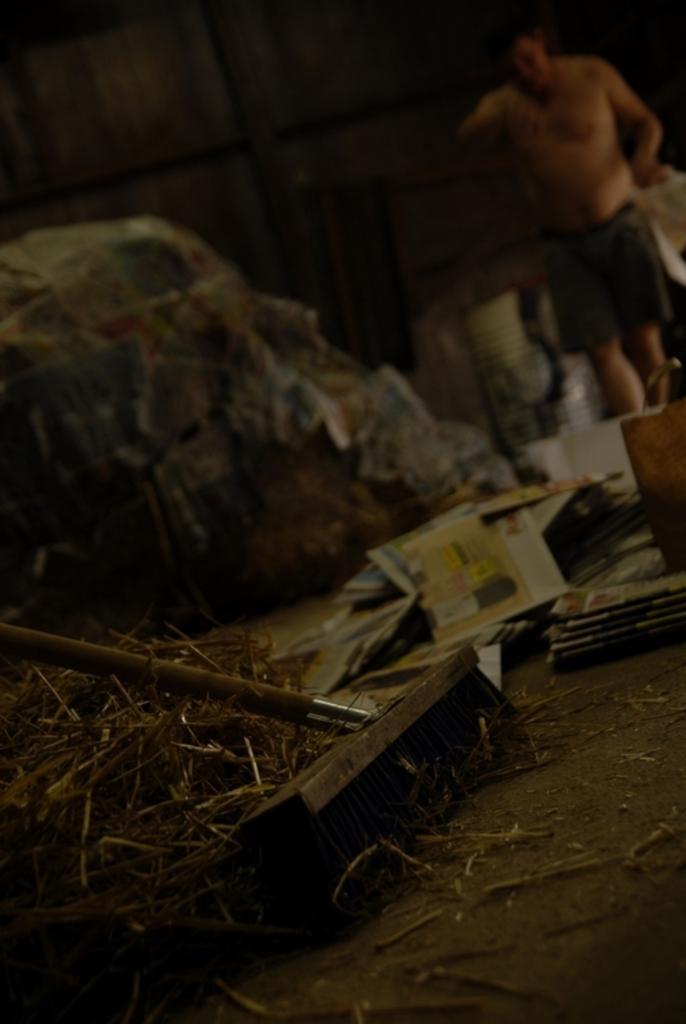Could you give a brief overview of what you see in this image? In this picture we can see grass, cleaning brush, paper, cover and objects on the floor. In the background it is blurry and we can see a man. 